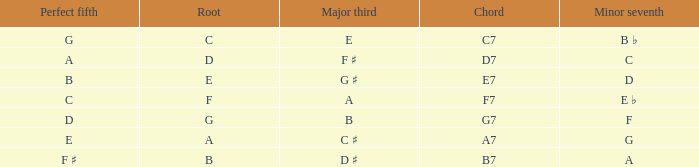What is the Perfect fifth with a Minor that is seventh of d? B. 